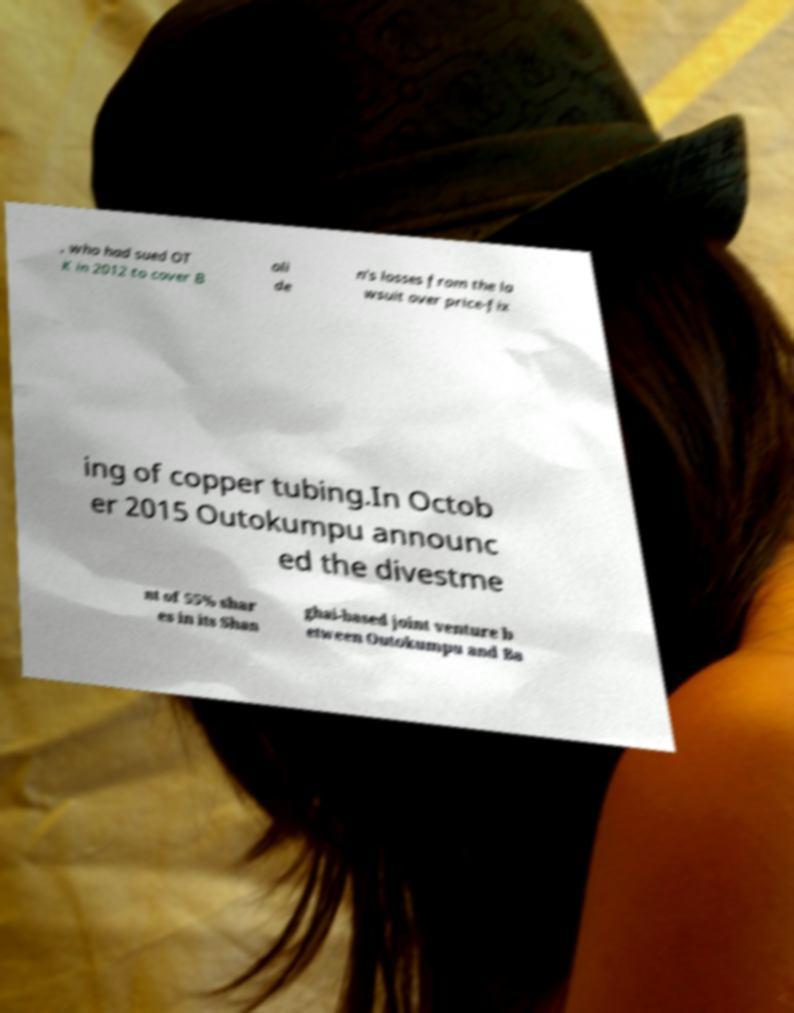Could you assist in decoding the text presented in this image and type it out clearly? , who had sued OT K in 2012 to cover B oli de n's losses from the la wsuit over price-fix ing of copper tubing.In Octob er 2015 Outokumpu announc ed the divestme nt of 55% shar es in its Shan ghai-based joint venture b etween Outokumpu and Ba 